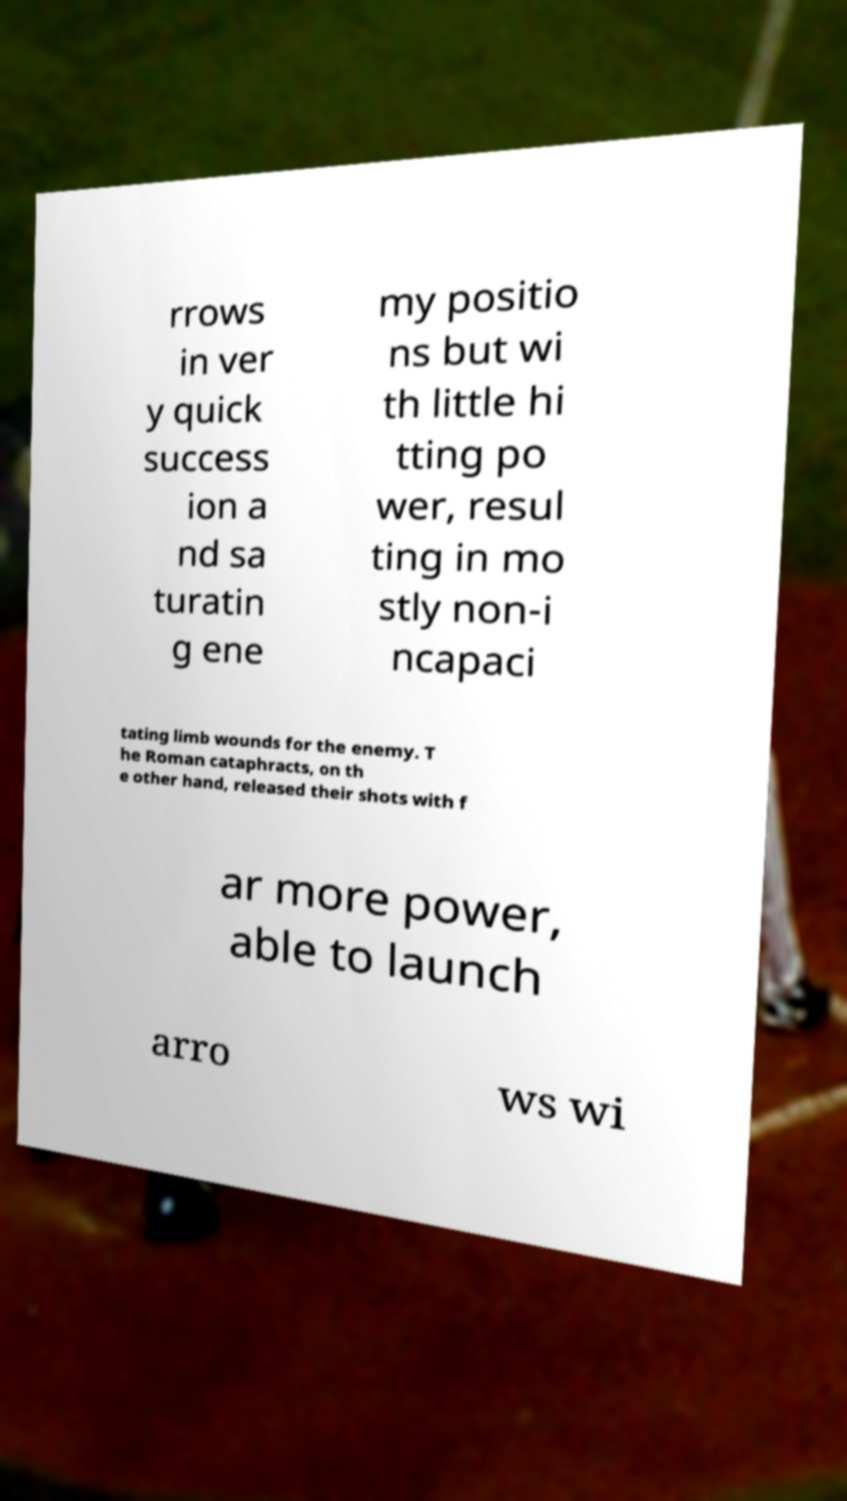For documentation purposes, I need the text within this image transcribed. Could you provide that? rrows in ver y quick success ion a nd sa turatin g ene my positio ns but wi th little hi tting po wer, resul ting in mo stly non-i ncapaci tating limb wounds for the enemy. T he Roman cataphracts, on th e other hand, released their shots with f ar more power, able to launch arro ws wi 